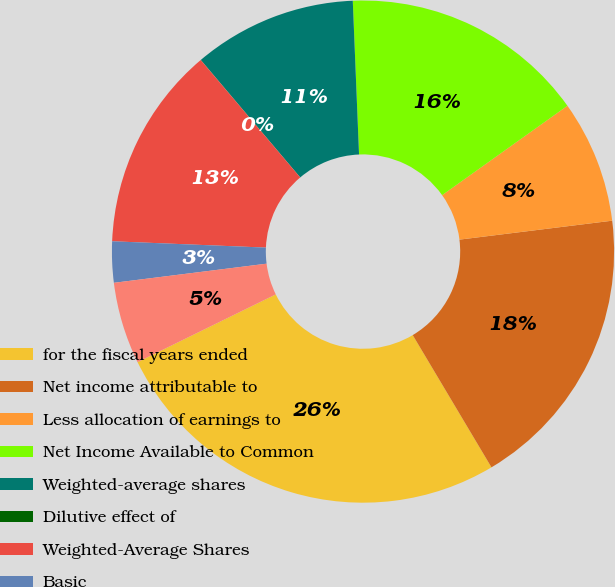Convert chart. <chart><loc_0><loc_0><loc_500><loc_500><pie_chart><fcel>for the fiscal years ended<fcel>Net income attributable to<fcel>Less allocation of earnings to<fcel>Net Income Available to Common<fcel>Weighted-average shares<fcel>Dilutive effect of<fcel>Weighted-Average Shares<fcel>Basic<fcel>Diluted<nl><fcel>26.3%<fcel>18.42%<fcel>7.9%<fcel>15.79%<fcel>10.53%<fcel>0.01%<fcel>13.16%<fcel>2.64%<fcel>5.27%<nl></chart> 